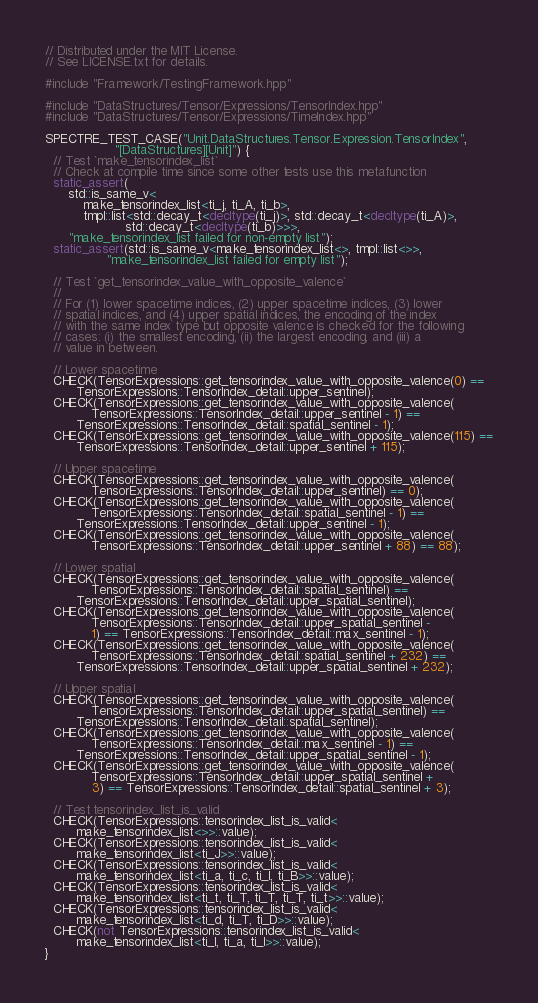Convert code to text. <code><loc_0><loc_0><loc_500><loc_500><_C++_>// Distributed under the MIT License.
// See LICENSE.txt for details.

#include "Framework/TestingFramework.hpp"

#include "DataStructures/Tensor/Expressions/TensorIndex.hpp"
#include "DataStructures/Tensor/Expressions/TimeIndex.hpp"

SPECTRE_TEST_CASE("Unit.DataStructures.Tensor.Expression.TensorIndex",
                  "[DataStructures][Unit]") {
  // Test `make_tensorindex_list`
  // Check at compile time since some other tests use this metafunction
  static_assert(
      std::is_same_v<
          make_tensorindex_list<ti_j, ti_A, ti_b>,
          tmpl::list<std::decay_t<decltype(ti_j)>, std::decay_t<decltype(ti_A)>,
                     std::decay_t<decltype(ti_b)>>>,
      "make_tensorindex_list failed for non-empty list");
  static_assert(std::is_same_v<make_tensorindex_list<>, tmpl::list<>>,
                "make_tensorindex_list failed for empty list");

  // Test `get_tensorindex_value_with_opposite_valence`
  //
  // For (1) lower spacetime indices, (2) upper spacetime indices, (3) lower
  // spatial indices, and (4) upper spatial indices, the encoding of the index
  // with the same index type but opposite valence is checked for the following
  // cases: (i) the smallest encoding, (ii) the largest encoding, and (iii) a
  // value in between.

  // Lower spacetime
  CHECK(TensorExpressions::get_tensorindex_value_with_opposite_valence(0) ==
        TensorExpressions::TensorIndex_detail::upper_sentinel);
  CHECK(TensorExpressions::get_tensorindex_value_with_opposite_valence(
            TensorExpressions::TensorIndex_detail::upper_sentinel - 1) ==
        TensorExpressions::TensorIndex_detail::spatial_sentinel - 1);
  CHECK(TensorExpressions::get_tensorindex_value_with_opposite_valence(115) ==
        TensorExpressions::TensorIndex_detail::upper_sentinel + 115);

  // Upper spacetime
  CHECK(TensorExpressions::get_tensorindex_value_with_opposite_valence(
            TensorExpressions::TensorIndex_detail::upper_sentinel) == 0);
  CHECK(TensorExpressions::get_tensorindex_value_with_opposite_valence(
            TensorExpressions::TensorIndex_detail::spatial_sentinel - 1) ==
        TensorExpressions::TensorIndex_detail::upper_sentinel - 1);
  CHECK(TensorExpressions::get_tensorindex_value_with_opposite_valence(
            TensorExpressions::TensorIndex_detail::upper_sentinel + 88) == 88);

  // Lower spatial
  CHECK(TensorExpressions::get_tensorindex_value_with_opposite_valence(
            TensorExpressions::TensorIndex_detail::spatial_sentinel) ==
        TensorExpressions::TensorIndex_detail::upper_spatial_sentinel);
  CHECK(TensorExpressions::get_tensorindex_value_with_opposite_valence(
            TensorExpressions::TensorIndex_detail::upper_spatial_sentinel -
            1) == TensorExpressions::TensorIndex_detail::max_sentinel - 1);
  CHECK(TensorExpressions::get_tensorindex_value_with_opposite_valence(
            TensorExpressions::TensorIndex_detail::spatial_sentinel + 232) ==
        TensorExpressions::TensorIndex_detail::upper_spatial_sentinel + 232);

  // Upper spatial
  CHECK(TensorExpressions::get_tensorindex_value_with_opposite_valence(
            TensorExpressions::TensorIndex_detail::upper_spatial_sentinel) ==
        TensorExpressions::TensorIndex_detail::spatial_sentinel);
  CHECK(TensorExpressions::get_tensorindex_value_with_opposite_valence(
            TensorExpressions::TensorIndex_detail::max_sentinel - 1) ==
        TensorExpressions::TensorIndex_detail::upper_spatial_sentinel - 1);
  CHECK(TensorExpressions::get_tensorindex_value_with_opposite_valence(
            TensorExpressions::TensorIndex_detail::upper_spatial_sentinel +
            3) == TensorExpressions::TensorIndex_detail::spatial_sentinel + 3);

  // Test tensorindex_list_is_valid
  CHECK(TensorExpressions::tensorindex_list_is_valid<
        make_tensorindex_list<>>::value);
  CHECK(TensorExpressions::tensorindex_list_is_valid<
        make_tensorindex_list<ti_J>>::value);
  CHECK(TensorExpressions::tensorindex_list_is_valid<
        make_tensorindex_list<ti_a, ti_c, ti_I, ti_B>>::value);
  CHECK(TensorExpressions::tensorindex_list_is_valid<
        make_tensorindex_list<ti_t, ti_T, ti_T, ti_T, ti_t>>::value);
  CHECK(TensorExpressions::tensorindex_list_is_valid<
        make_tensorindex_list<ti_d, ti_T, ti_D>>::value);
  CHECK(not TensorExpressions::tensorindex_list_is_valid<
        make_tensorindex_list<ti_I, ti_a, ti_I>>::value);
}
</code> 